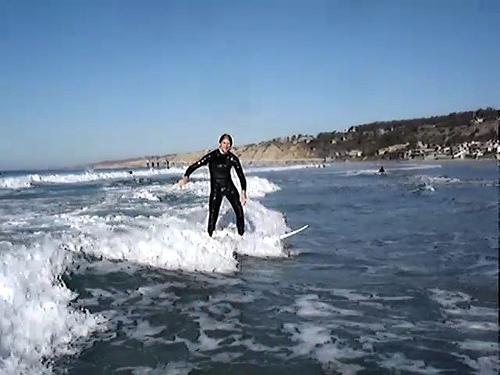How many people are there?
Give a very brief answer. 1. How many people are in the photo?
Give a very brief answer. 1. 